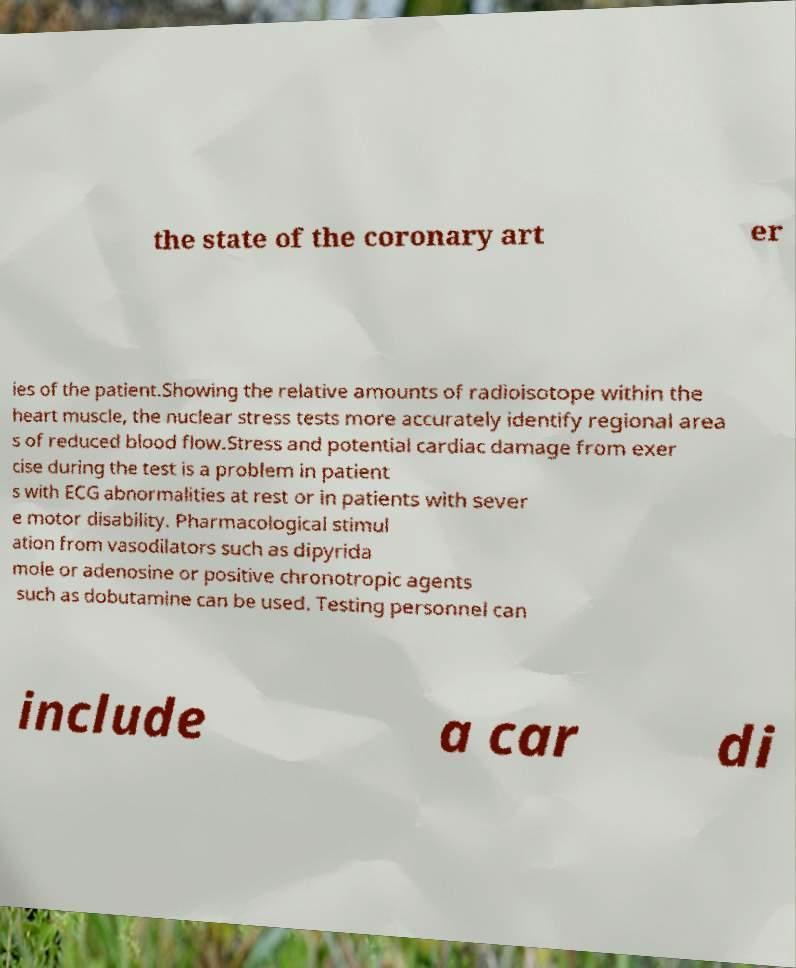Could you extract and type out the text from this image? the state of the coronary art er ies of the patient.Showing the relative amounts of radioisotope within the heart muscle, the nuclear stress tests more accurately identify regional area s of reduced blood flow.Stress and potential cardiac damage from exer cise during the test is a problem in patient s with ECG abnormalities at rest or in patients with sever e motor disability. Pharmacological stimul ation from vasodilators such as dipyrida mole or adenosine or positive chronotropic agents such as dobutamine can be used. Testing personnel can include a car di 